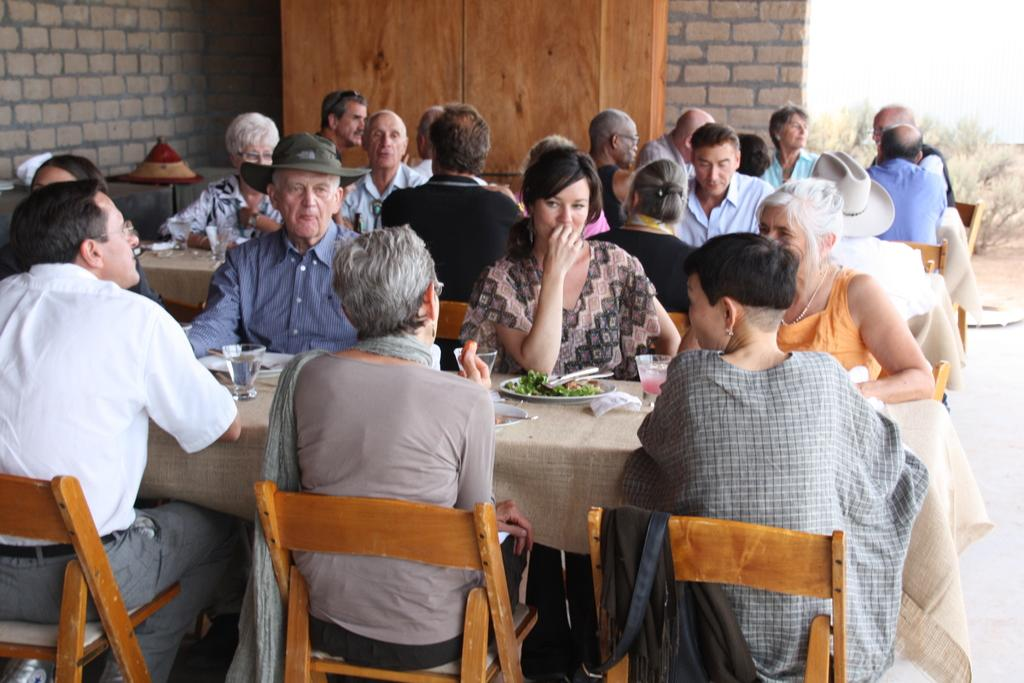What are the people in the image doing? The people in the image are sitting on chairs. What are the tables in front of the people used for? The tables are used to hold food and other items. What type of items can be seen on the tables? Besides food, there are other things on the tables. What can be seen in the background of the image? There is a wall in the background of the image. Can you tell me how many dogs are sitting on the chairs in the image? There are no dogs present in the image; only people are sitting on the chairs. 